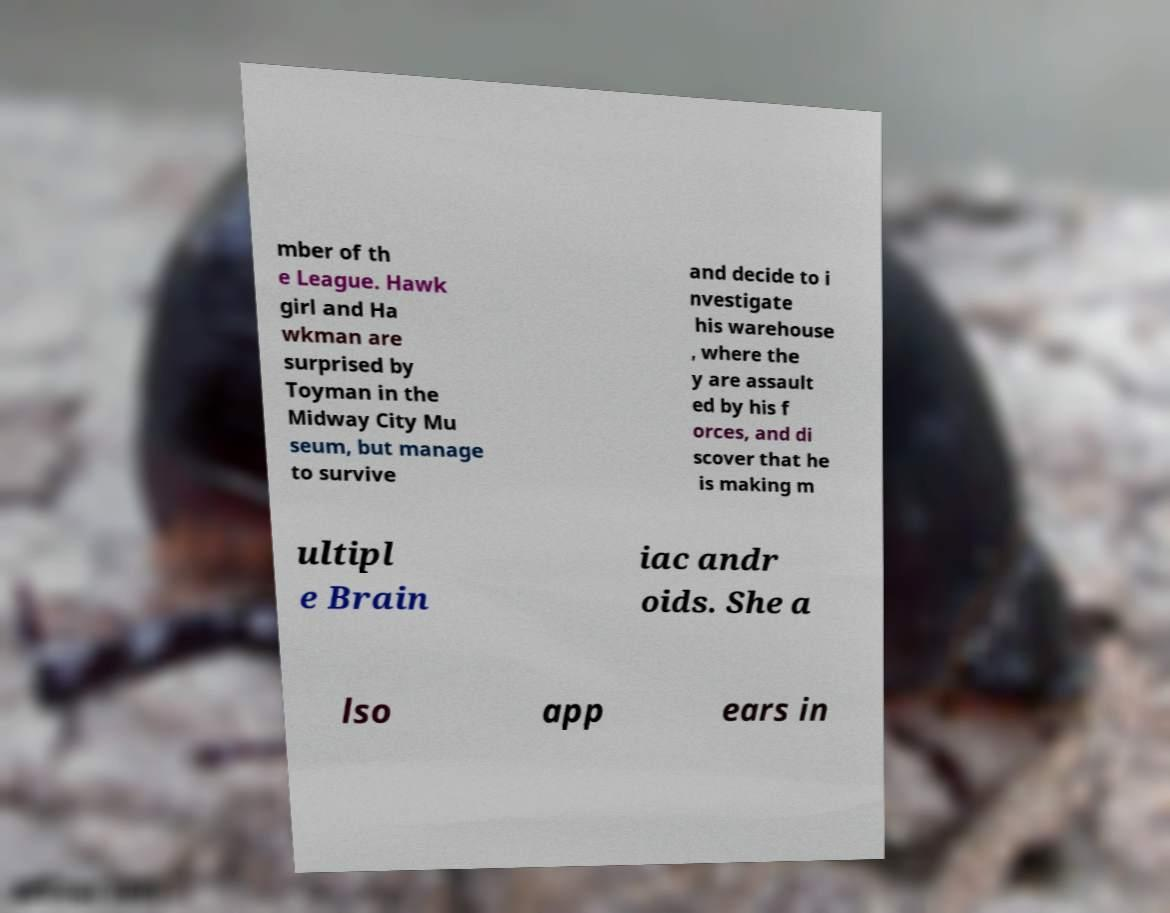What messages or text are displayed in this image? I need them in a readable, typed format. mber of th e League. Hawk girl and Ha wkman are surprised by Toyman in the Midway City Mu seum, but manage to survive and decide to i nvestigate his warehouse , where the y are assault ed by his f orces, and di scover that he is making m ultipl e Brain iac andr oids. She a lso app ears in 